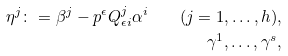<formula> <loc_0><loc_0><loc_500><loc_500>\eta ^ { j } \colon = \beta ^ { j } - p ^ { \epsilon } Q ^ { j } _ { \epsilon i } \alpha ^ { i } \quad ( j = 1 , \dots , h ) , \\ \gamma ^ { 1 } , \dots , \gamma ^ { s } ,</formula> 